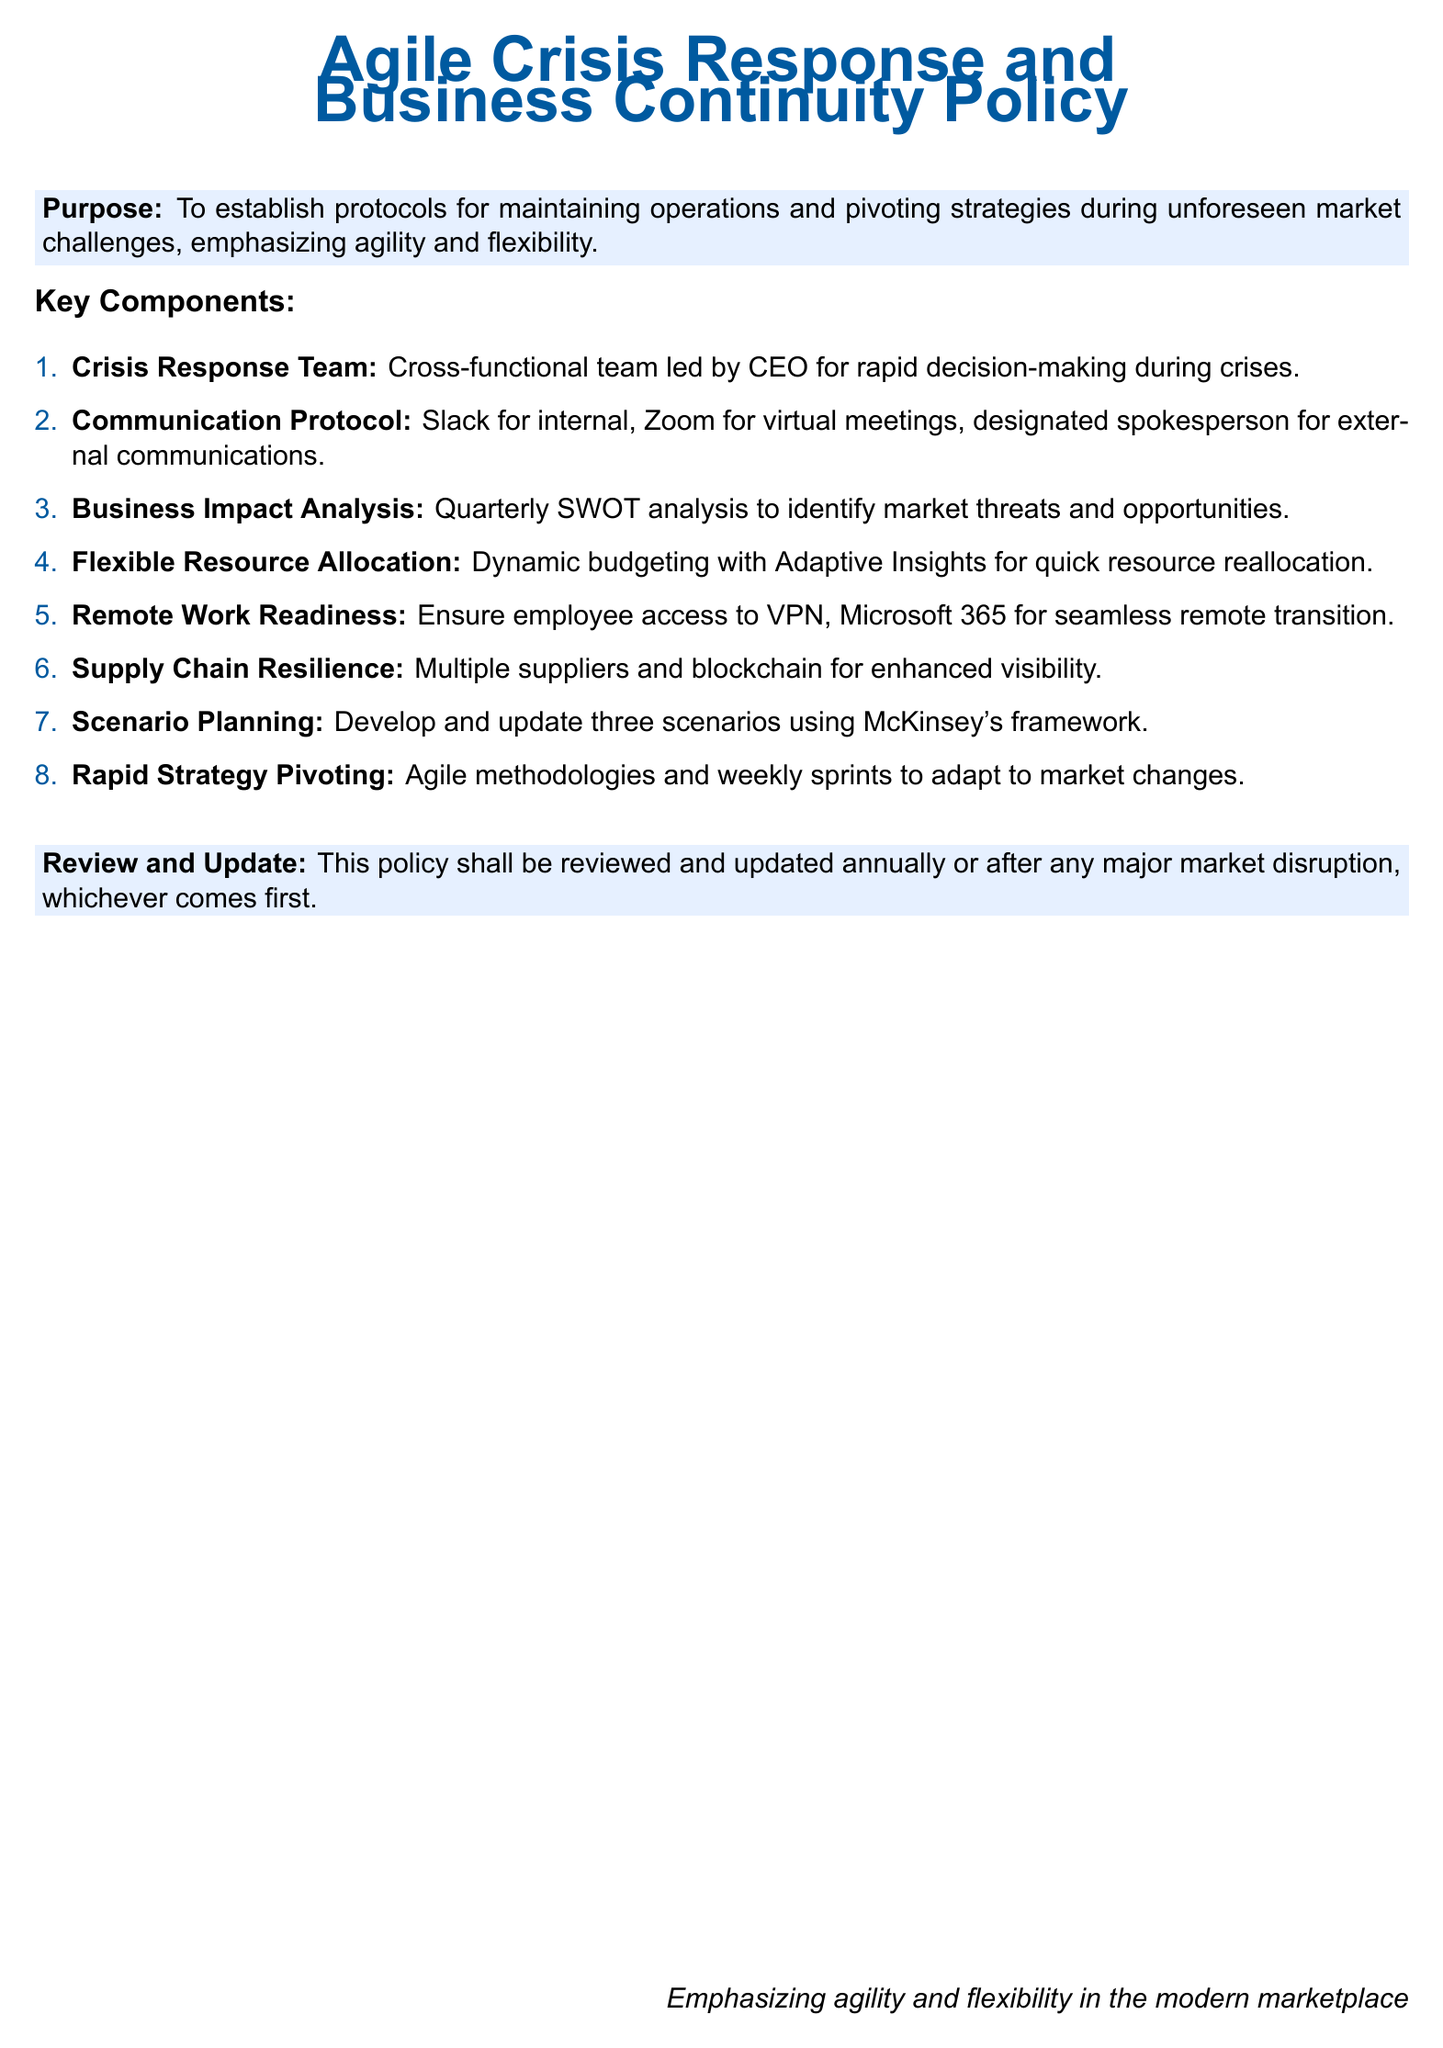What is the purpose of the policy? The purpose is to establish protocols for maintaining operations and pivoting strategies during unforeseen market challenges, emphasizing agility and flexibility.
Answer: To establish protocols for maintaining operations and pivoting strategies during unforeseen market challenges, emphasizing agility and flexibility Who leads the Crisis Response Team? The document states that the Crisis Response Team is led by the CEO for rapid decision-making during crises.
Answer: CEO How often is the Business Impact Analysis conducted? According to the document, the Business Impact Analysis is conducted quarterly.
Answer: Quarterly What tools are mentioned for remote work readiness? The document specifies that employees should have access to VPN and Microsoft 365 for a seamless remote transition.
Answer: VPN, Microsoft 365 What is the frequency of reviewing and updating the policy? The document states that the policy shall be reviewed and updated annually or after any major market disruption.
Answer: Annually What does the policy emphasize in the modern marketplace? The document highlights the importance of agility and flexibility in the modern marketplace.
Answer: Agility and flexibility What framework is used for scenario planning? The document mentions using McKinsey's framework for developing and updating scenarios.
Answer: McKinsey's framework What is the key method for rapid strategy pivoting mentioned? The document indicates that agile methodologies and weekly sprints are used for rapid strategy pivoting.
Answer: Agile methodologies and weekly sprints 